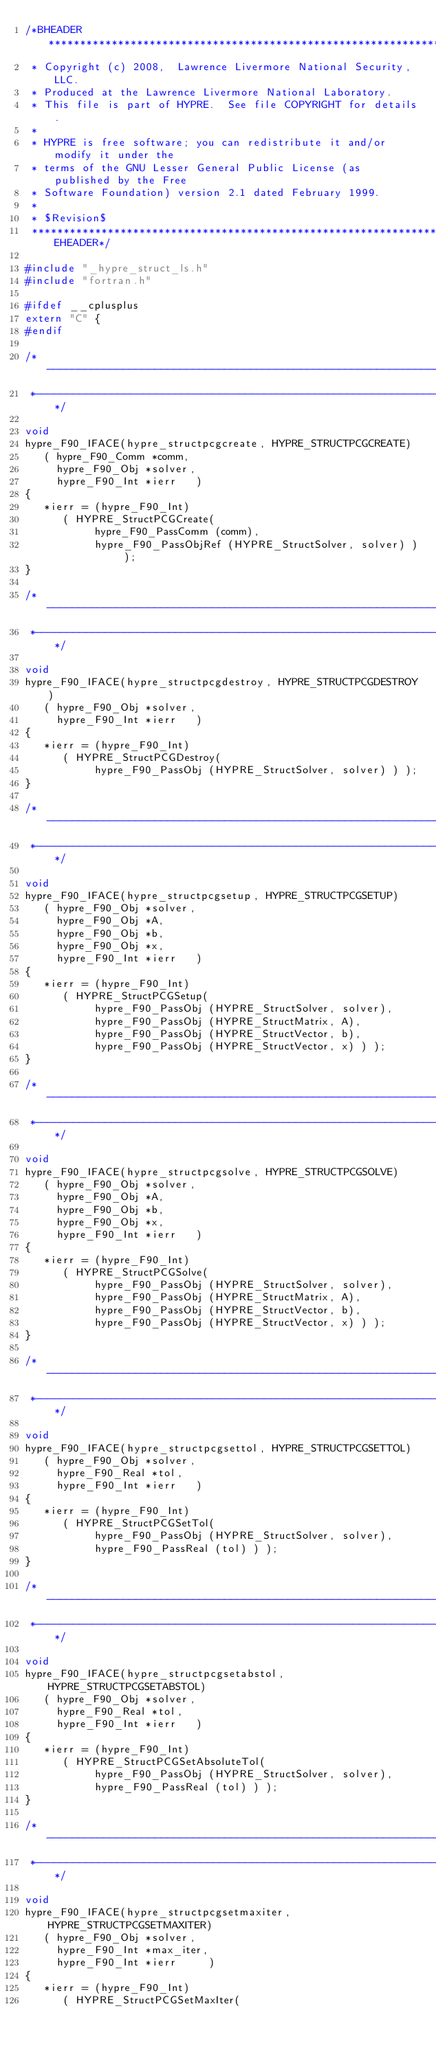Convert code to text. <code><loc_0><loc_0><loc_500><loc_500><_C_>/*BHEADER**********************************************************************
 * Copyright (c) 2008,  Lawrence Livermore National Security, LLC.
 * Produced at the Lawrence Livermore National Laboratory.
 * This file is part of HYPRE.  See file COPYRIGHT for details.
 *
 * HYPRE is free software; you can redistribute it and/or modify it under the
 * terms of the GNU Lesser General Public License (as published by the Free
 * Software Foundation) version 2.1 dated February 1999.
 *
 * $Revision$
 ***********************************************************************EHEADER*/

#include "_hypre_struct_ls.h"
#include "fortran.h"

#ifdef __cplusplus
extern "C" {
#endif
    
/*--------------------------------------------------------------------------
 *--------------------------------------------------------------------------*/

void
hypre_F90_IFACE(hypre_structpcgcreate, HYPRE_STRUCTPCGCREATE)
   ( hypre_F90_Comm *comm,
     hypre_F90_Obj *solver,
     hypre_F90_Int *ierr   )
{
   *ierr = (hypre_F90_Int)
      ( HYPRE_StructPCGCreate(
           hypre_F90_PassComm (comm),
           hypre_F90_PassObjRef (HYPRE_StructSolver, solver) ) );
}

/*--------------------------------------------------------------------------
 *--------------------------------------------------------------------------*/

void 
hypre_F90_IFACE(hypre_structpcgdestroy, HYPRE_STRUCTPCGDESTROY)
   ( hypre_F90_Obj *solver,
     hypre_F90_Int *ierr   )
{
   *ierr = (hypre_F90_Int)
      ( HYPRE_StructPCGDestroy(
           hypre_F90_PassObj (HYPRE_StructSolver, solver) ) );
}

/*--------------------------------------------------------------------------
 *--------------------------------------------------------------------------*/

void 
hypre_F90_IFACE(hypre_structpcgsetup, HYPRE_STRUCTPCGSETUP)
   ( hypre_F90_Obj *solver,
     hypre_F90_Obj *A,
     hypre_F90_Obj *b,
     hypre_F90_Obj *x,
     hypre_F90_Int *ierr   )
{
   *ierr = (hypre_F90_Int)
      ( HYPRE_StructPCGSetup(
           hypre_F90_PassObj (HYPRE_StructSolver, solver),
           hypre_F90_PassObj (HYPRE_StructMatrix, A),
           hypre_F90_PassObj (HYPRE_StructVector, b),
           hypre_F90_PassObj (HYPRE_StructVector, x) ) );
}

/*--------------------------------------------------------------------------
 *--------------------------------------------------------------------------*/

void 
hypre_F90_IFACE(hypre_structpcgsolve, HYPRE_STRUCTPCGSOLVE)
   ( hypre_F90_Obj *solver,
     hypre_F90_Obj *A,
     hypre_F90_Obj *b,
     hypre_F90_Obj *x,
     hypre_F90_Int *ierr   )
{
   *ierr = (hypre_F90_Int)
      ( HYPRE_StructPCGSolve(
           hypre_F90_PassObj (HYPRE_StructSolver, solver),
           hypre_F90_PassObj (HYPRE_StructMatrix, A),
           hypre_F90_PassObj (HYPRE_StructVector, b),
           hypre_F90_PassObj (HYPRE_StructVector, x) ) );
}

/*--------------------------------------------------------------------------
 *--------------------------------------------------------------------------*/

void
hypre_F90_IFACE(hypre_structpcgsettol, HYPRE_STRUCTPCGSETTOL)
   ( hypre_F90_Obj *solver,
     hypre_F90_Real *tol,
     hypre_F90_Int *ierr   )
{
   *ierr = (hypre_F90_Int)
      ( HYPRE_StructPCGSetTol(
           hypre_F90_PassObj (HYPRE_StructSolver, solver),
           hypre_F90_PassReal (tol) ) );
}

/*--------------------------------------------------------------------------
 *--------------------------------------------------------------------------*/

void
hypre_F90_IFACE(hypre_structpcgsetabstol, HYPRE_STRUCTPCGSETABSTOL)
   ( hypre_F90_Obj *solver,
     hypre_F90_Real *tol,
     hypre_F90_Int *ierr   )
{
   *ierr = (hypre_F90_Int)
      ( HYPRE_StructPCGSetAbsoluteTol(
           hypre_F90_PassObj (HYPRE_StructSolver, solver),
           hypre_F90_PassReal (tol) ) );
}

/*--------------------------------------------------------------------------
 *--------------------------------------------------------------------------*/

void
hypre_F90_IFACE(hypre_structpcgsetmaxiter, HYPRE_STRUCTPCGSETMAXITER)
   ( hypre_F90_Obj *solver,
     hypre_F90_Int *max_iter,
     hypre_F90_Int *ierr     )
{
   *ierr = (hypre_F90_Int)
      ( HYPRE_StructPCGSetMaxIter(</code> 